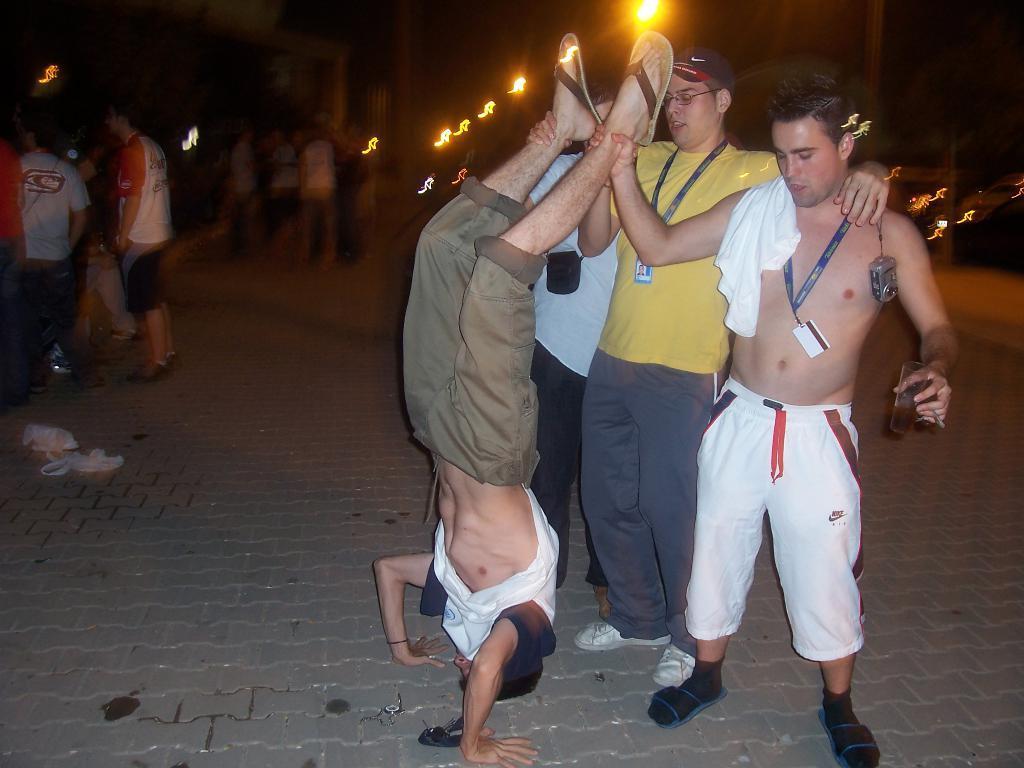Please provide a concise description of this image. In this image there is a footpath. There are people standing on the footpath. There are street lights and there is a road. 